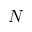Convert formula to latex. <formula><loc_0><loc_0><loc_500><loc_500>N</formula> 